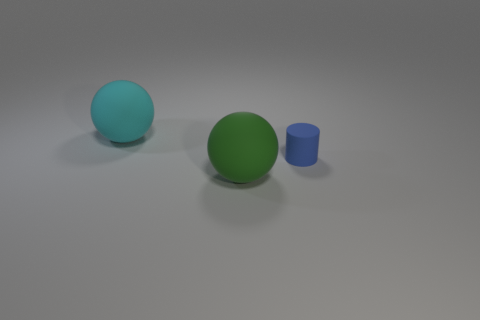There is a big rubber ball that is to the right of the big sphere that is behind the tiny blue thing; are there any blue cylinders that are to the left of it?
Give a very brief answer. No. How many tiny objects have the same color as the cylinder?
Make the answer very short. 0. Are there any large rubber spheres in front of the blue matte object?
Your response must be concise. Yes. Does the green rubber ball have the same size as the cyan rubber ball?
Offer a terse response. Yes. There is a rubber object right of the big green sphere; what is its shape?
Provide a short and direct response. Cylinder. Is there a object of the same size as the blue cylinder?
Give a very brief answer. No. There is a cyan sphere that is the same size as the green thing; what is its material?
Make the answer very short. Rubber. There is a sphere in front of the cyan sphere; what is its size?
Offer a terse response. Large. How big is the cylinder?
Ensure brevity in your answer.  Small. Do the blue cylinder and the ball right of the cyan matte object have the same size?
Your response must be concise. No. 